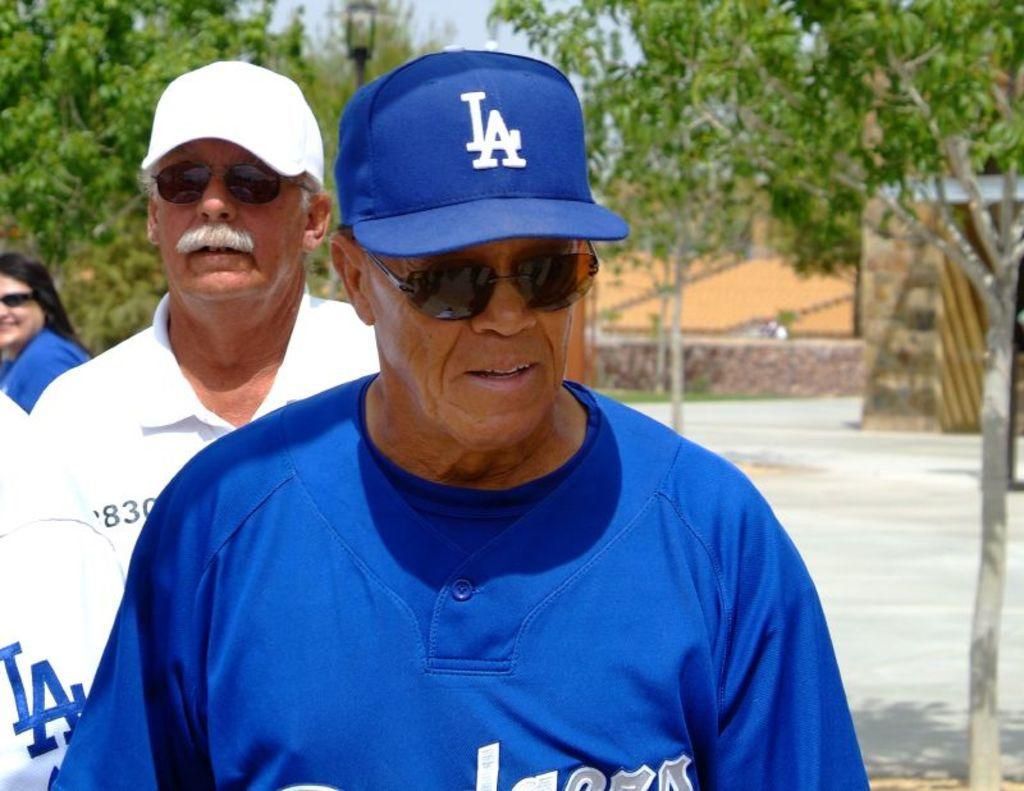Who can be seen in the image? There are persons in the front of the image, including a woman in the center. What can be seen in the background of the image? There are trees, a pole, and a wall in the background of the image. What is the woman in the center of the image doing? The woman is smiling. What type of cakes are displayed in the frame in the image? There is no frame or cakes present in the image. What mode of transportation is available at the station in the image? There is no station or mode of transportation present in the image. 